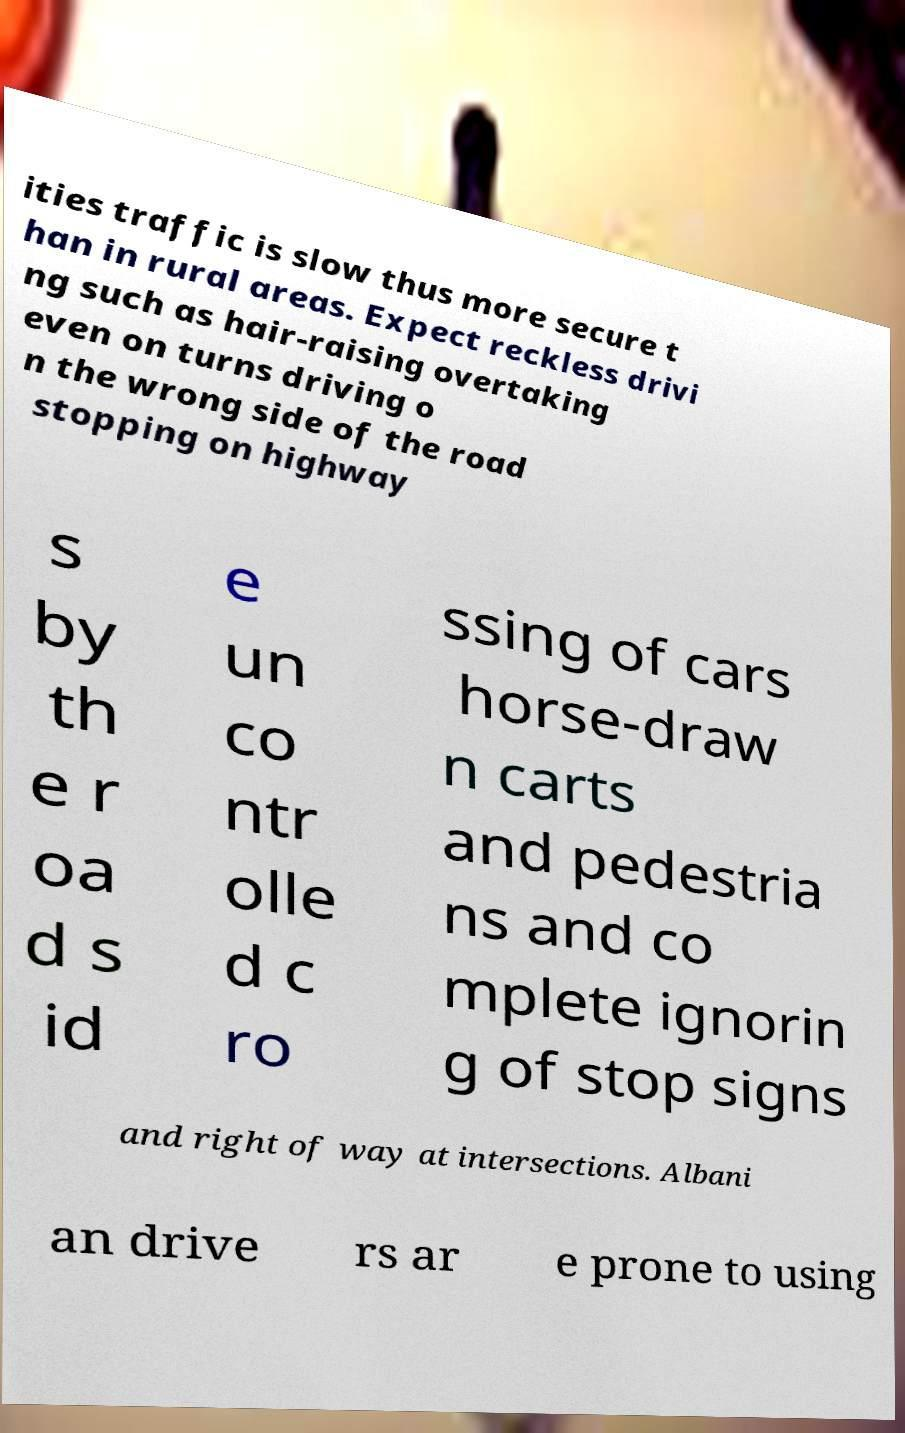There's text embedded in this image that I need extracted. Can you transcribe it verbatim? ities traffic is slow thus more secure t han in rural areas. Expect reckless drivi ng such as hair-raising overtaking even on turns driving o n the wrong side of the road stopping on highway s by th e r oa d s id e un co ntr olle d c ro ssing of cars horse-draw n carts and pedestria ns and co mplete ignorin g of stop signs and right of way at intersections. Albani an drive rs ar e prone to using 